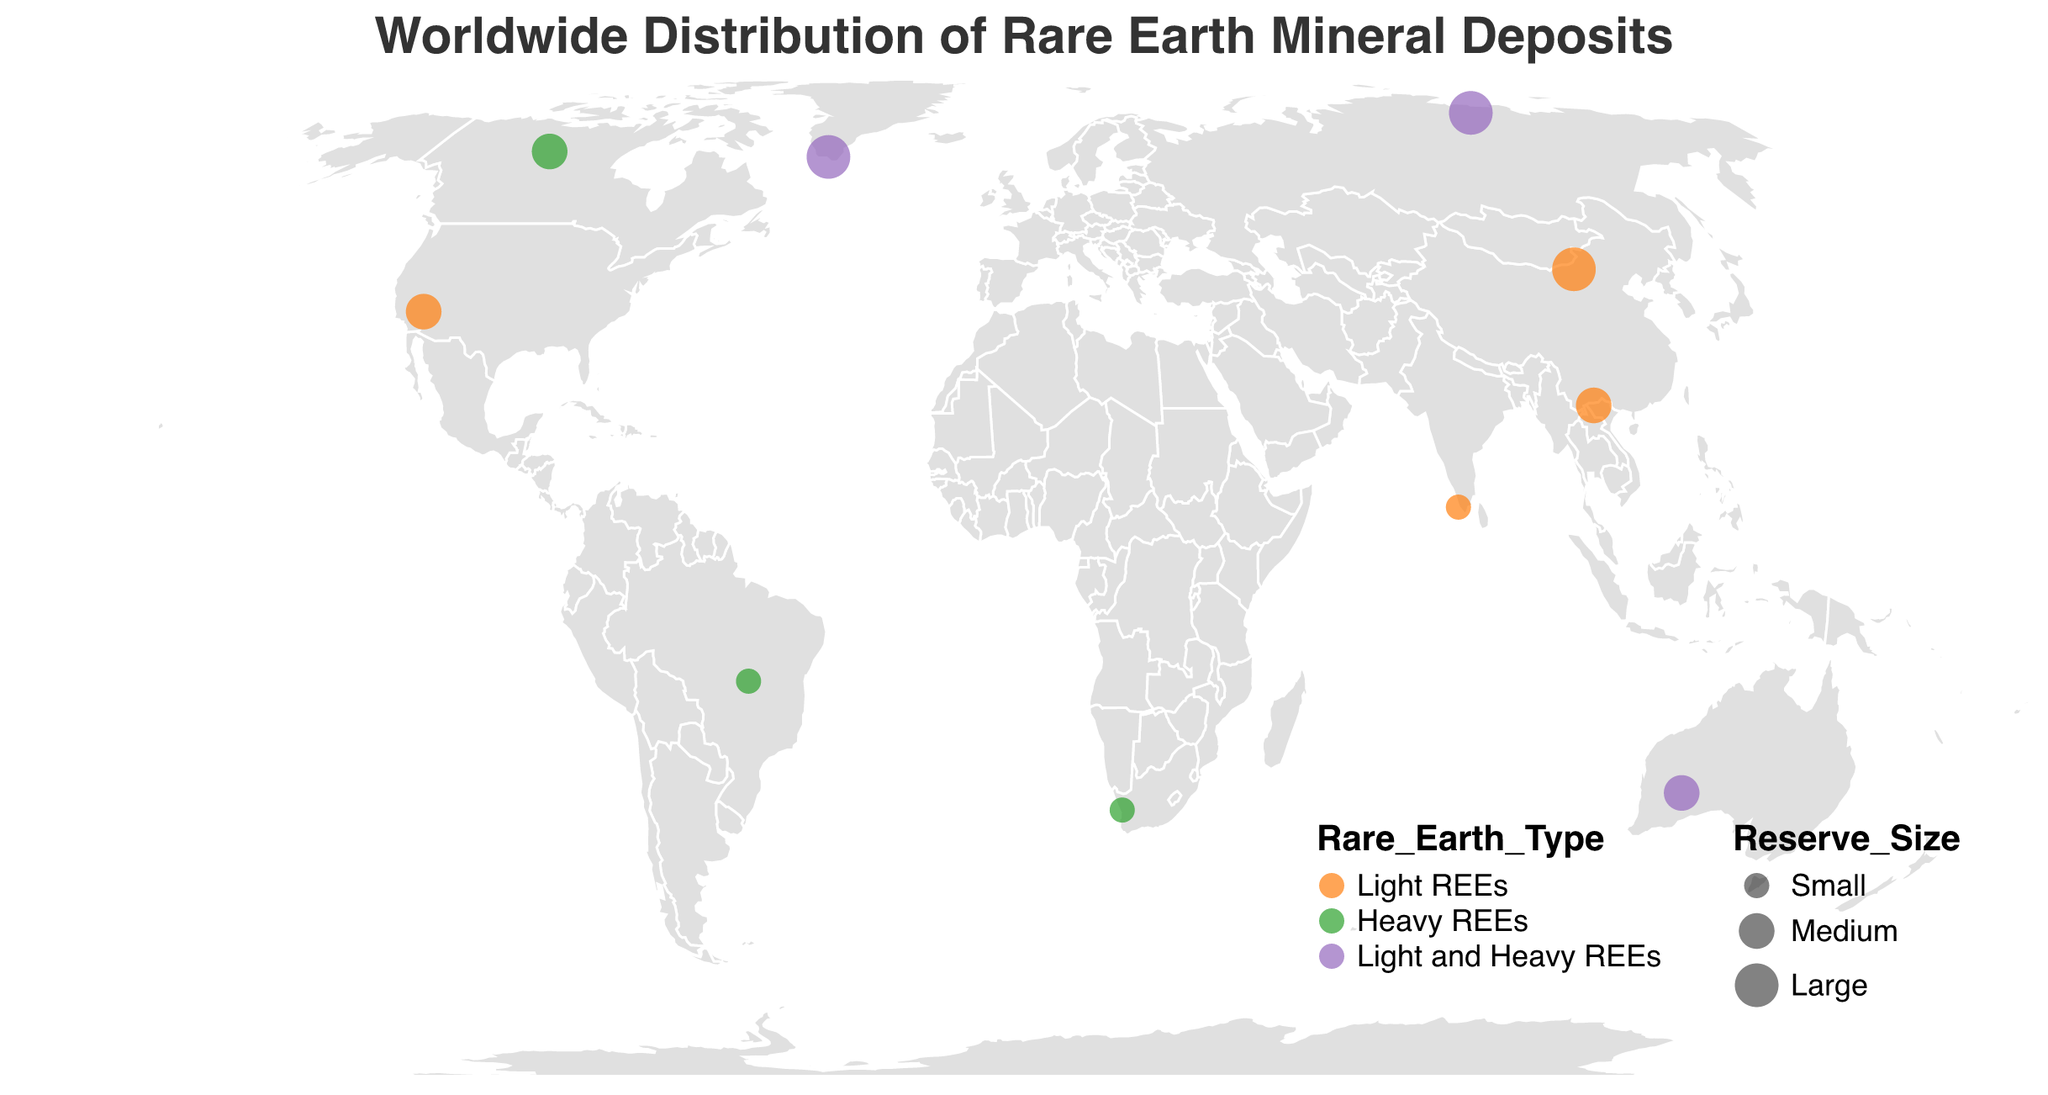How many countries have rare earth mineral deposits labeled on the map? Count the number of unique countries listed in the data.
Answer: 10 Which country has the largest deposit size according to the map? Look for the data point with the largest size circle on the map.
Answer: China What is the strategic importance of the rare earth deposit in the United States? Refer to the tooltip data for the United States (Mountain Pass).
Answer: Domestic supply for tech industry Which deposits include both light and heavy rare earth elements? Look for deposits where the "Rare_Earth_Type" field is "Light and Heavy REEs". These deposits are Mount Weld (Australia), Tomtor (Russia), and Kvanefjeld (Greenland).
Answer: Mount Weld, Tomtor, Kvanefjeld Compare the reserve sizes of the deposits in Brazil and Canada. Which one is larger? Check the "Reserve_Size" field for Serra Verde (Brazil) and Thor Lake (Canada). Brazil has a "Small" reserve size while Canada has a "Medium" reserve size.
Answer: Canada Where is the deposit with the highest strategic importance located? Look for the deposit entry with "Critical for magnets and electronics" in the "Strategic_Importance" field and note its coordinates (China, Bayan Obo).
Answer: China What is the latitude of the deposit in Greenland? Refer to the "lat" field for the deposit named Kvanefjeld in Greenland.
Answer: 61.0 Find the countries with a strategic importance that includes "Diversification." Search the "Strategic_Importance" field for entries that contain the word "Diversification" and list their countries: Australia (Mount Weld) and South Africa (Steenkampskraal).
Answer: Australia, South Africa Which deposit is noted as having a medium reserve size but only light rare earth elements? Search for deposits with "Medium" reserve size and "Light REEs" as the type. The result is Mountain Pass (United States) and Lai Chau (Vietnam).
Answer: Mountain Pass, Lai Chau Which country has deposits that provide strategic geopolitical leverage? Refer to the "Strategic_Importance" field and identify the deposit listed as providing "Geopolitical leverage". This is Tomtor in Russia.
Answer: Russia 